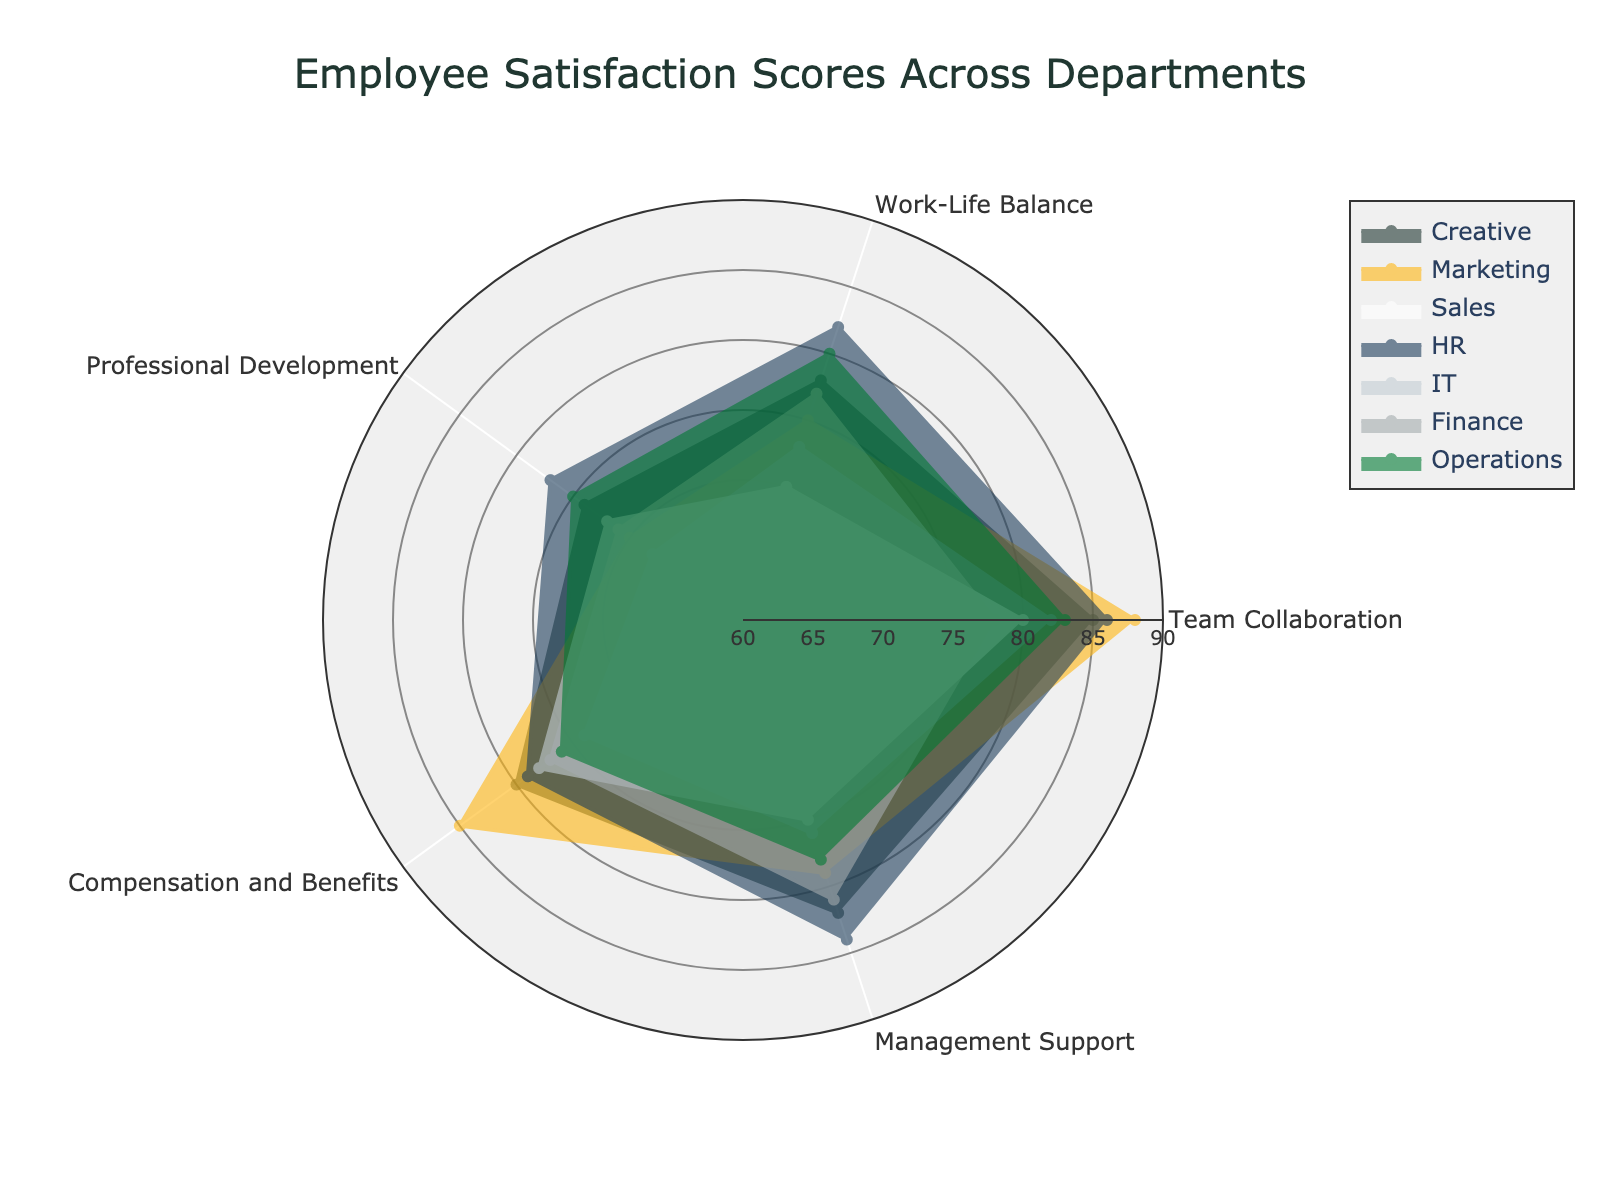What is the title of the figure? The title is displayed at the top of the figure, usually in a larger font size to capture attention.
Answer: Employee Satisfaction Scores Across Departments Which department has the highest score in Team Collaboration? Look for the department with the highest value along the Team Collaboration axis.
Answer: Marketing Which area in the radar chart appears to have the smallest range of scores across all departments? Analyze the extent of variation in scores for each category by visually comparing the distances from the center.
Answer: Compensation and Benefits How does the HR department's score in Management Support compare to the IT department's score in the same category? Compare the scores of the HR and IT departments by looking at the Management Support axis.
Answer: HR has a higher score What is the average score for Professional Development across all departments? Sum the Professional Development scores for all departments and divide by the number of departments: (74 + 70 + 68 + 77 + 72 + 71 + 75) / 7 = 507 / 7 = 72.43
Answer: 72.43 Which department shows the most balanced scores across all categories? Look for the department with the most consistent spread across the radar chart, with less fluctuation between categories.
Answer: HR By how much does the Creative department's score in Work-Life Balance differ from its score in Team Collaboration? Subtract the Work-Life Balance score from the Team Collaboration score for the Creative department: 85 - 78 = 7
Answer: 7 Which category has the lowest average score across all departments? Calculate the average score for each category and identify the lowest: 
Team Collaboration: (85+88+82+86+80+78+83)/7 = 83.14 
Work-Life Balance: (78+75+73+82+70+77+80)/7 = 76.43 
Professional Development: (74+70+68+77+72+71+75)/7 = 72.43 
Compensation and Benefits: (80+85+74+79+78+77+76)/7 = 78.43 
Management Support: (82+79+76+84+75+81+78)/7 = 79.29
The lowest average is for Professional Development.
Answer: Professional Development Which two departments have the closest scores in Compensation and Benefits? Compare the scores in the Compensation and Benefits category and identify the two departments with the least difference in scores: Finance (77) and IT (78)
Answer: Finance and IT How does the variation in Work-Life Balance scores compare to the variation in Professional Development scores? Evaluate the spread of scores for Work-Life Balance and Professional Development by assessing their minimum and maximum values. 
Work-Life Balance: range = 70 to 82 = 12 
Professional Development: range = 68 to 77 = 9. The Work-Life Balance scores have a larger range.
Answer: Work-Life Balance scores have a larger range 